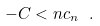Convert formula to latex. <formula><loc_0><loc_0><loc_500><loc_500>- C < n c _ { n } \ .</formula> 